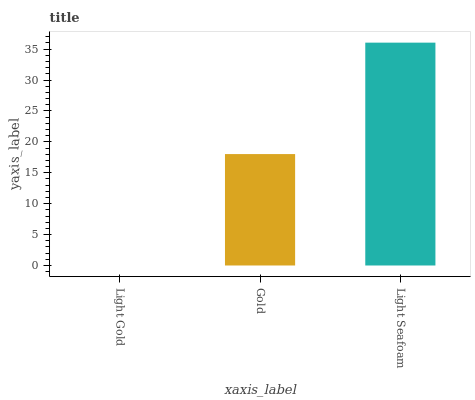Is Light Gold the minimum?
Answer yes or no. Yes. Is Light Seafoam the maximum?
Answer yes or no. Yes. Is Gold the minimum?
Answer yes or no. No. Is Gold the maximum?
Answer yes or no. No. Is Gold greater than Light Gold?
Answer yes or no. Yes. Is Light Gold less than Gold?
Answer yes or no. Yes. Is Light Gold greater than Gold?
Answer yes or no. No. Is Gold less than Light Gold?
Answer yes or no. No. Is Gold the high median?
Answer yes or no. Yes. Is Gold the low median?
Answer yes or no. Yes. Is Light Gold the high median?
Answer yes or no. No. Is Light Seafoam the low median?
Answer yes or no. No. 